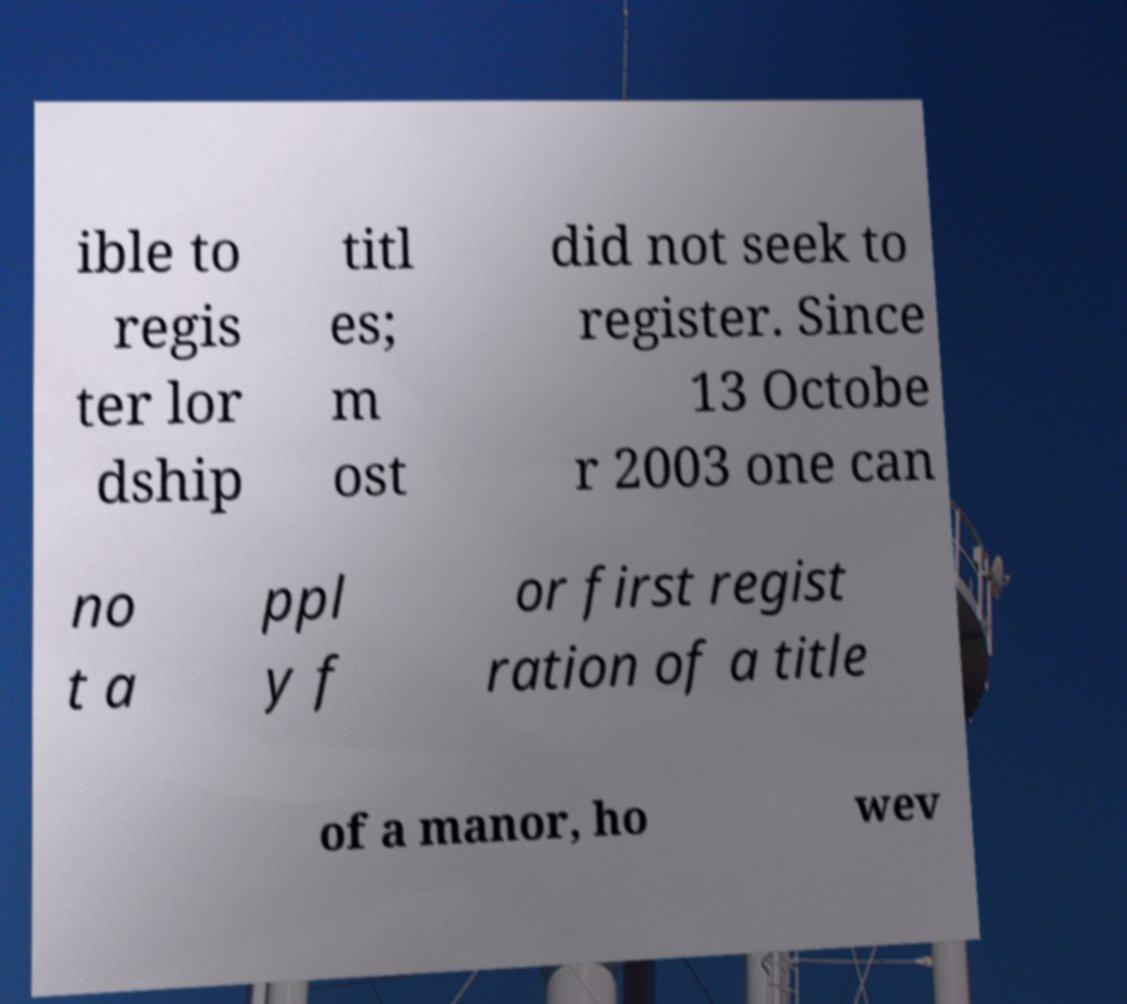What messages or text are displayed in this image? I need them in a readable, typed format. ible to regis ter lor dship titl es; m ost did not seek to register. Since 13 Octobe r 2003 one can no t a ppl y f or first regist ration of a title of a manor, ho wev 